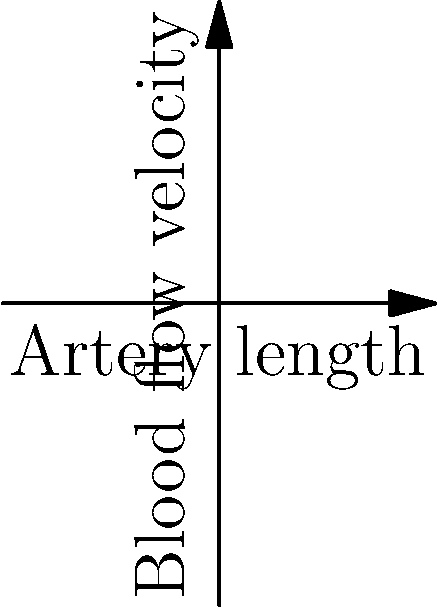In a medical drama, a character experiences severe chest pain due to coronary artery disease. The attending physician explains that the patient's coronary arteries have significant stenosis, reducing blood flow. Based on the fluid dynamics of blood flow through arteries with different levels of stenosis, as shown in the graph, what is the relationship between the maximum velocity of blood flow in a stenotic artery ($v_s$) compared to a normal artery ($v_n$) of the same diameter? To answer this question, we need to understand the principles of fluid dynamics in blood vessels:

1. The graph shows the velocity profile of blood flow in a normal artery (blue curve) and a stenotic artery (red curve).

2. According to the continuity equation in fluid dynamics, the volumetric flow rate (Q) must remain constant throughout a closed system:

   $Q = A_1v_1 = A_2v_2$

   Where A is the cross-sectional area, and v is the velocity.

3. In a stenotic artery, the cross-sectional area (A) is reduced due to the narrowing of the vessel.

4. To maintain the same flow rate with a smaller cross-sectional area, the velocity must increase in the stenotic region.

5. From the graph, we can see that the maximum velocity in the stenotic artery ($v_s$) is lower than in the normal artery ($v_n$).

6. This apparent contradiction is resolved by considering that the graph shows velocity profiles across the entire length of the arteries, not just at the point of stenosis.

7. The overall reduced velocity in the stenotic artery is due to increased resistance to flow, caused by the narrowing.

8. However, at the specific point of maximum stenosis (not shown in the graph), the velocity would be higher than in the normal artery to maintain the same volumetric flow rate.

Therefore, while the graph shows lower overall velocities in the stenotic artery, the relationship between $v_s$ and $v_n$ at the point of maximum stenosis would be $v_s > v_n$.
Answer: $v_s > v_n$ at the point of maximum stenosis 